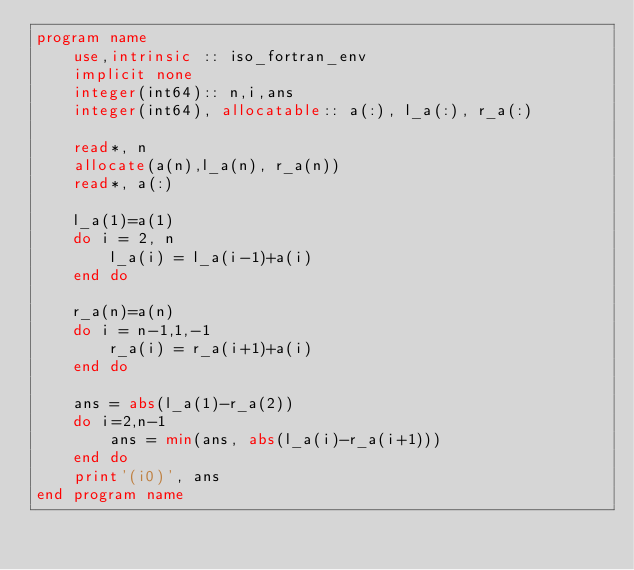<code> <loc_0><loc_0><loc_500><loc_500><_FORTRAN_>program name
    use,intrinsic :: iso_fortran_env
    implicit none
    integer(int64):: n,i,ans
    integer(int64), allocatable:: a(:), l_a(:), r_a(:)

    read*, n
    allocate(a(n),l_a(n), r_a(n))
    read*, a(:)

    l_a(1)=a(1)
    do i = 2, n
        l_a(i) = l_a(i-1)+a(i)
    end do

    r_a(n)=a(n)
    do i = n-1,1,-1
        r_a(i) = r_a(i+1)+a(i)
    end do

    ans = abs(l_a(1)-r_a(2))
    do i=2,n-1
        ans = min(ans, abs(l_a(i)-r_a(i+1)))
    end do
    print'(i0)', ans
end program name</code> 